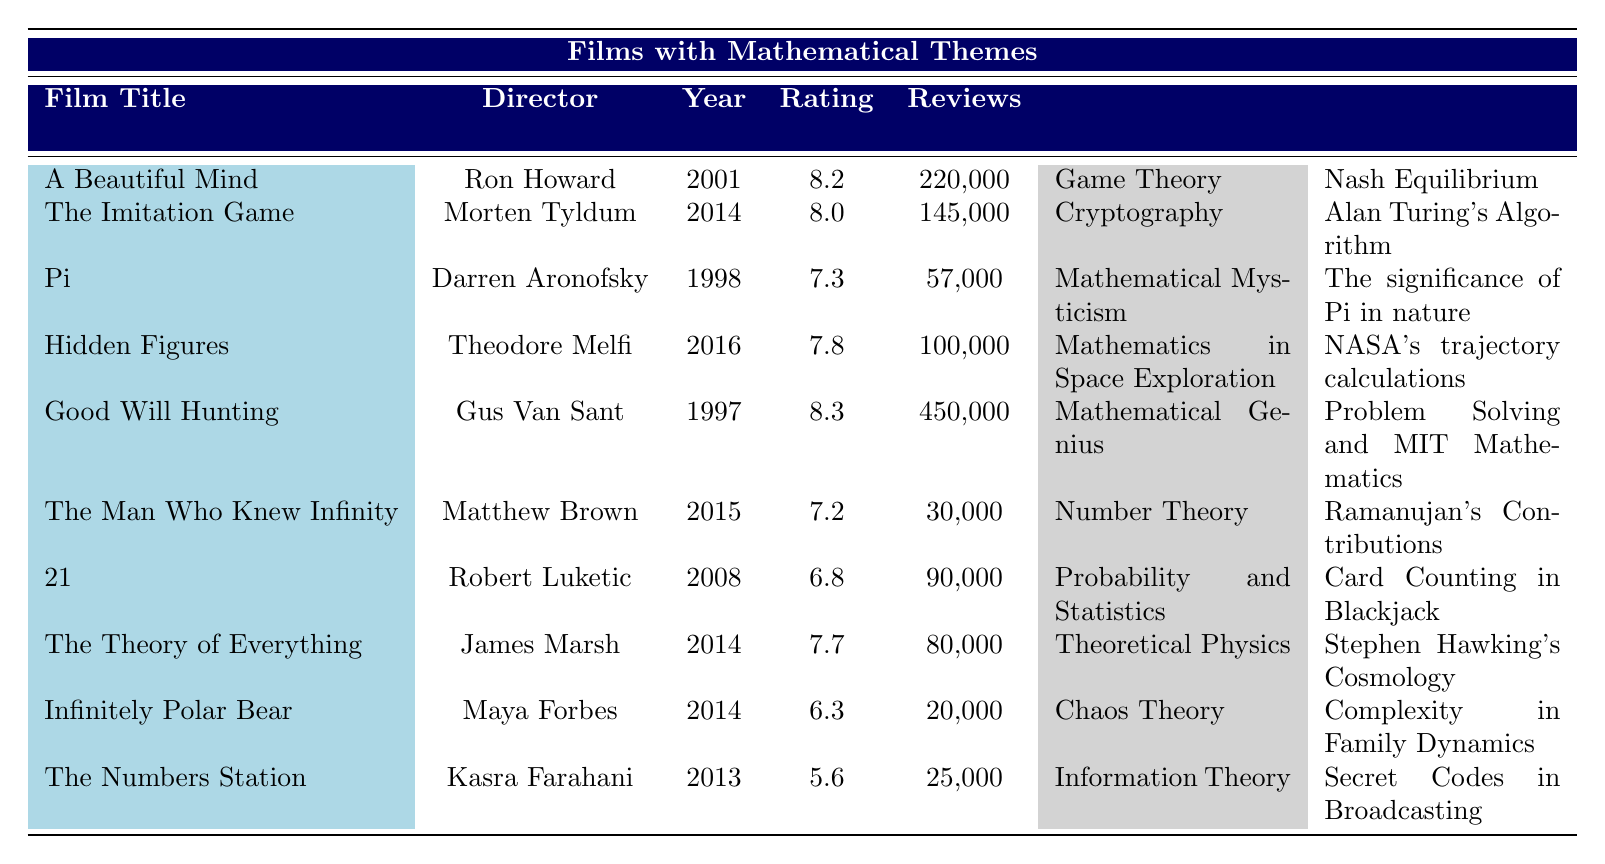What is the highest audience rating among the films listed? By reviewing the audience ratings in the table, "Good Will Hunting" has the highest rating of 8.3.
Answer: 8.3 Which film explores the theme of Chaos Theory? The film "Infinitely Polar Bear" is listed with the theme of Chaos Theory.
Answer: Infinitely Polar Bear What is the average audience rating of the films with a mathematical theme? To find the average, add up all the ratings: (8.2 + 8.0 + 7.3 + 7.8 + 8.3 + 7.2 + 6.8 + 7.7 + 6.3 + 5.6) = 77.0 and then divide by the number of films (10) to get an average rating of 7.7.
Answer: 7.7 How many reviews were recorded for "The Imitation Game"? The number of reviews recorded for "The Imitation Game" is directly provided in the table as 145,000.
Answer: 145,000 Is there a film about Cryptography that has a higher audience rating than "Hidden Figures"? "The Imitation Game," which focuses on Cryptography, has a rating of 8.0, which is higher than "Hidden Figures" at 7.8.
Answer: Yes Which film has the lowest audience rating, and what is it? By scanning the table for audience ratings, "The Numbers Station" has the lowest rating of 5.6.
Answer: The Numbers Station, 5.6 What is the total number of reviews for films that discuss Probability and Statistics? The table shows that "21" has 90,000 reviews. Since it is the only film in this category, the total is also 90,000.
Answer: 90,000 How many films have an audience rating of 8.0 or higher? There are four films that have ratings of 8.0 or higher: "A Beautiful Mind" (8.2), "The Imitation Game" (8.0), "Good Will Hunting" (8.3), and "Hidden Figures" (7.8), which does not qualify. Thus, this totals to 3 films.
Answer: 3 Find the difference in reviews between "Good Will Hunting" and "The Man Who Knew Infinity." "Good Will Hunting" has 450,000 reviews and "The Man Who Knew Infinity" has 30,000 reviews. The difference is 450,000 - 30,000 = 420,000.
Answer: 420,000 Are there more people who reviewed films on Game Theory or Number Theory? "A Beautiful Mind" (Game Theory) has 220,000 reviews, while "The Man Who Knew Infinity" (Number Theory) has 30,000 reviews. Therefore, more reviews were for Game Theory.
Answer: Yes, Game Theory has more reviews 